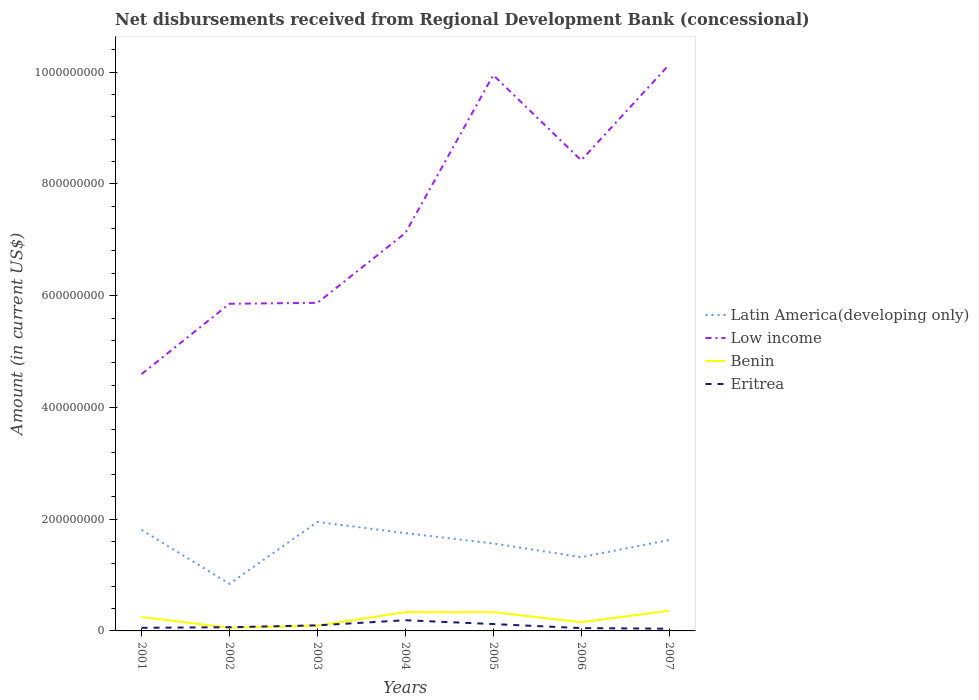How many different coloured lines are there?
Provide a succinct answer. 4. Does the line corresponding to Low income intersect with the line corresponding to Benin?
Your answer should be very brief. No. Is the number of lines equal to the number of legend labels?
Provide a succinct answer. Yes. Across all years, what is the maximum amount of disbursements received from Regional Development Bank in Benin?
Provide a short and direct response. 5.64e+06. In which year was the amount of disbursements received from Regional Development Bank in Eritrea maximum?
Offer a very short reply. 2007. What is the total amount of disbursements received from Regional Development Bank in Latin America(developing only) in the graph?
Offer a terse response. -9.08e+07. What is the difference between the highest and the second highest amount of disbursements received from Regional Development Bank in Eritrea?
Keep it short and to the point. 1.51e+07. What is the difference between the highest and the lowest amount of disbursements received from Regional Development Bank in Benin?
Provide a short and direct response. 4. Is the amount of disbursements received from Regional Development Bank in Low income strictly greater than the amount of disbursements received from Regional Development Bank in Benin over the years?
Your response must be concise. No. How many years are there in the graph?
Your answer should be very brief. 7. Where does the legend appear in the graph?
Ensure brevity in your answer.  Center right. How many legend labels are there?
Make the answer very short. 4. How are the legend labels stacked?
Your answer should be compact. Vertical. What is the title of the graph?
Your response must be concise. Net disbursements received from Regional Development Bank (concessional). Does "Spain" appear as one of the legend labels in the graph?
Keep it short and to the point. No. What is the label or title of the X-axis?
Offer a very short reply. Years. What is the Amount (in current US$) in Latin America(developing only) in 2001?
Give a very brief answer. 1.81e+08. What is the Amount (in current US$) of Low income in 2001?
Provide a succinct answer. 4.60e+08. What is the Amount (in current US$) in Benin in 2001?
Your answer should be very brief. 2.50e+07. What is the Amount (in current US$) in Eritrea in 2001?
Keep it short and to the point. 5.58e+06. What is the Amount (in current US$) in Latin America(developing only) in 2002?
Keep it short and to the point. 8.43e+07. What is the Amount (in current US$) of Low income in 2002?
Make the answer very short. 5.86e+08. What is the Amount (in current US$) in Benin in 2002?
Your answer should be very brief. 5.64e+06. What is the Amount (in current US$) of Eritrea in 2002?
Your answer should be compact. 6.65e+06. What is the Amount (in current US$) in Latin America(developing only) in 2003?
Keep it short and to the point. 1.95e+08. What is the Amount (in current US$) of Low income in 2003?
Your answer should be very brief. 5.87e+08. What is the Amount (in current US$) in Benin in 2003?
Offer a terse response. 9.45e+06. What is the Amount (in current US$) in Eritrea in 2003?
Keep it short and to the point. 9.97e+06. What is the Amount (in current US$) of Latin America(developing only) in 2004?
Your response must be concise. 1.75e+08. What is the Amount (in current US$) of Low income in 2004?
Keep it short and to the point. 7.12e+08. What is the Amount (in current US$) of Benin in 2004?
Your answer should be compact. 3.37e+07. What is the Amount (in current US$) in Eritrea in 2004?
Give a very brief answer. 1.91e+07. What is the Amount (in current US$) in Latin America(developing only) in 2005?
Offer a terse response. 1.57e+08. What is the Amount (in current US$) of Low income in 2005?
Keep it short and to the point. 9.95e+08. What is the Amount (in current US$) in Benin in 2005?
Offer a terse response. 3.36e+07. What is the Amount (in current US$) in Eritrea in 2005?
Give a very brief answer. 1.23e+07. What is the Amount (in current US$) of Latin America(developing only) in 2006?
Your answer should be very brief. 1.32e+08. What is the Amount (in current US$) of Low income in 2006?
Provide a short and direct response. 8.42e+08. What is the Amount (in current US$) in Benin in 2006?
Give a very brief answer. 1.55e+07. What is the Amount (in current US$) in Eritrea in 2006?
Your response must be concise. 5.05e+06. What is the Amount (in current US$) in Latin America(developing only) in 2007?
Give a very brief answer. 1.63e+08. What is the Amount (in current US$) of Low income in 2007?
Your answer should be compact. 1.01e+09. What is the Amount (in current US$) in Benin in 2007?
Offer a terse response. 3.63e+07. What is the Amount (in current US$) of Eritrea in 2007?
Your answer should be compact. 3.99e+06. Across all years, what is the maximum Amount (in current US$) of Latin America(developing only)?
Your answer should be compact. 1.95e+08. Across all years, what is the maximum Amount (in current US$) in Low income?
Offer a terse response. 1.01e+09. Across all years, what is the maximum Amount (in current US$) in Benin?
Give a very brief answer. 3.63e+07. Across all years, what is the maximum Amount (in current US$) of Eritrea?
Your response must be concise. 1.91e+07. Across all years, what is the minimum Amount (in current US$) of Latin America(developing only)?
Your response must be concise. 8.43e+07. Across all years, what is the minimum Amount (in current US$) of Low income?
Make the answer very short. 4.60e+08. Across all years, what is the minimum Amount (in current US$) of Benin?
Offer a terse response. 5.64e+06. Across all years, what is the minimum Amount (in current US$) in Eritrea?
Your answer should be very brief. 3.99e+06. What is the total Amount (in current US$) of Latin America(developing only) in the graph?
Give a very brief answer. 1.09e+09. What is the total Amount (in current US$) of Low income in the graph?
Your answer should be very brief. 5.20e+09. What is the total Amount (in current US$) of Benin in the graph?
Your answer should be very brief. 1.59e+08. What is the total Amount (in current US$) in Eritrea in the graph?
Ensure brevity in your answer.  6.27e+07. What is the difference between the Amount (in current US$) in Latin America(developing only) in 2001 and that in 2002?
Ensure brevity in your answer.  9.65e+07. What is the difference between the Amount (in current US$) in Low income in 2001 and that in 2002?
Provide a short and direct response. -1.26e+08. What is the difference between the Amount (in current US$) of Benin in 2001 and that in 2002?
Offer a terse response. 1.93e+07. What is the difference between the Amount (in current US$) in Eritrea in 2001 and that in 2002?
Ensure brevity in your answer.  -1.07e+06. What is the difference between the Amount (in current US$) in Latin America(developing only) in 2001 and that in 2003?
Your answer should be very brief. -1.43e+07. What is the difference between the Amount (in current US$) in Low income in 2001 and that in 2003?
Provide a succinct answer. -1.28e+08. What is the difference between the Amount (in current US$) of Benin in 2001 and that in 2003?
Ensure brevity in your answer.  1.55e+07. What is the difference between the Amount (in current US$) of Eritrea in 2001 and that in 2003?
Your answer should be very brief. -4.39e+06. What is the difference between the Amount (in current US$) in Latin America(developing only) in 2001 and that in 2004?
Make the answer very short. 5.72e+06. What is the difference between the Amount (in current US$) of Low income in 2001 and that in 2004?
Offer a very short reply. -2.53e+08. What is the difference between the Amount (in current US$) of Benin in 2001 and that in 2004?
Offer a very short reply. -8.68e+06. What is the difference between the Amount (in current US$) in Eritrea in 2001 and that in 2004?
Provide a short and direct response. -1.36e+07. What is the difference between the Amount (in current US$) in Latin America(developing only) in 2001 and that in 2005?
Your response must be concise. 2.43e+07. What is the difference between the Amount (in current US$) in Low income in 2001 and that in 2005?
Provide a short and direct response. -5.35e+08. What is the difference between the Amount (in current US$) of Benin in 2001 and that in 2005?
Keep it short and to the point. -8.61e+06. What is the difference between the Amount (in current US$) of Eritrea in 2001 and that in 2005?
Offer a very short reply. -6.71e+06. What is the difference between the Amount (in current US$) in Latin America(developing only) in 2001 and that in 2006?
Provide a succinct answer. 4.88e+07. What is the difference between the Amount (in current US$) in Low income in 2001 and that in 2006?
Your answer should be compact. -3.83e+08. What is the difference between the Amount (in current US$) in Benin in 2001 and that in 2006?
Your answer should be compact. 9.44e+06. What is the difference between the Amount (in current US$) in Eritrea in 2001 and that in 2006?
Provide a succinct answer. 5.27e+05. What is the difference between the Amount (in current US$) of Latin America(developing only) in 2001 and that in 2007?
Ensure brevity in your answer.  1.81e+07. What is the difference between the Amount (in current US$) of Low income in 2001 and that in 2007?
Your answer should be very brief. -5.54e+08. What is the difference between the Amount (in current US$) of Benin in 2001 and that in 2007?
Offer a very short reply. -1.13e+07. What is the difference between the Amount (in current US$) of Eritrea in 2001 and that in 2007?
Offer a terse response. 1.59e+06. What is the difference between the Amount (in current US$) of Latin America(developing only) in 2002 and that in 2003?
Your response must be concise. -1.11e+08. What is the difference between the Amount (in current US$) in Low income in 2002 and that in 2003?
Provide a succinct answer. -1.66e+06. What is the difference between the Amount (in current US$) of Benin in 2002 and that in 2003?
Keep it short and to the point. -3.81e+06. What is the difference between the Amount (in current US$) of Eritrea in 2002 and that in 2003?
Make the answer very short. -3.32e+06. What is the difference between the Amount (in current US$) in Latin America(developing only) in 2002 and that in 2004?
Offer a terse response. -9.08e+07. What is the difference between the Amount (in current US$) in Low income in 2002 and that in 2004?
Your answer should be very brief. -1.27e+08. What is the difference between the Amount (in current US$) of Benin in 2002 and that in 2004?
Your answer should be very brief. -2.80e+07. What is the difference between the Amount (in current US$) in Eritrea in 2002 and that in 2004?
Keep it short and to the point. -1.25e+07. What is the difference between the Amount (in current US$) in Latin America(developing only) in 2002 and that in 2005?
Your answer should be compact. -7.22e+07. What is the difference between the Amount (in current US$) in Low income in 2002 and that in 2005?
Provide a short and direct response. -4.09e+08. What is the difference between the Amount (in current US$) in Benin in 2002 and that in 2005?
Ensure brevity in your answer.  -2.80e+07. What is the difference between the Amount (in current US$) in Eritrea in 2002 and that in 2005?
Provide a short and direct response. -5.64e+06. What is the difference between the Amount (in current US$) of Latin America(developing only) in 2002 and that in 2006?
Ensure brevity in your answer.  -4.77e+07. What is the difference between the Amount (in current US$) in Low income in 2002 and that in 2006?
Your response must be concise. -2.57e+08. What is the difference between the Amount (in current US$) of Benin in 2002 and that in 2006?
Your answer should be compact. -9.90e+06. What is the difference between the Amount (in current US$) in Eritrea in 2002 and that in 2006?
Your answer should be compact. 1.60e+06. What is the difference between the Amount (in current US$) of Latin America(developing only) in 2002 and that in 2007?
Offer a very short reply. -7.84e+07. What is the difference between the Amount (in current US$) of Low income in 2002 and that in 2007?
Your answer should be very brief. -4.28e+08. What is the difference between the Amount (in current US$) of Benin in 2002 and that in 2007?
Make the answer very short. -3.06e+07. What is the difference between the Amount (in current US$) in Eritrea in 2002 and that in 2007?
Offer a very short reply. 2.66e+06. What is the difference between the Amount (in current US$) in Latin America(developing only) in 2003 and that in 2004?
Ensure brevity in your answer.  2.00e+07. What is the difference between the Amount (in current US$) in Low income in 2003 and that in 2004?
Give a very brief answer. -1.25e+08. What is the difference between the Amount (in current US$) in Benin in 2003 and that in 2004?
Give a very brief answer. -2.42e+07. What is the difference between the Amount (in current US$) of Eritrea in 2003 and that in 2004?
Make the answer very short. -9.17e+06. What is the difference between the Amount (in current US$) in Latin America(developing only) in 2003 and that in 2005?
Make the answer very short. 3.85e+07. What is the difference between the Amount (in current US$) of Low income in 2003 and that in 2005?
Your answer should be compact. -4.08e+08. What is the difference between the Amount (in current US$) of Benin in 2003 and that in 2005?
Your answer should be very brief. -2.41e+07. What is the difference between the Amount (in current US$) of Eritrea in 2003 and that in 2005?
Offer a terse response. -2.32e+06. What is the difference between the Amount (in current US$) of Latin America(developing only) in 2003 and that in 2006?
Provide a succinct answer. 6.31e+07. What is the difference between the Amount (in current US$) of Low income in 2003 and that in 2006?
Your answer should be compact. -2.55e+08. What is the difference between the Amount (in current US$) of Benin in 2003 and that in 2006?
Make the answer very short. -6.09e+06. What is the difference between the Amount (in current US$) in Eritrea in 2003 and that in 2006?
Provide a succinct answer. 4.91e+06. What is the difference between the Amount (in current US$) of Latin America(developing only) in 2003 and that in 2007?
Your response must be concise. 3.23e+07. What is the difference between the Amount (in current US$) in Low income in 2003 and that in 2007?
Your answer should be compact. -4.26e+08. What is the difference between the Amount (in current US$) of Benin in 2003 and that in 2007?
Give a very brief answer. -2.68e+07. What is the difference between the Amount (in current US$) in Eritrea in 2003 and that in 2007?
Provide a succinct answer. 5.98e+06. What is the difference between the Amount (in current US$) of Latin America(developing only) in 2004 and that in 2005?
Make the answer very short. 1.86e+07. What is the difference between the Amount (in current US$) of Low income in 2004 and that in 2005?
Your response must be concise. -2.83e+08. What is the difference between the Amount (in current US$) of Benin in 2004 and that in 2005?
Offer a very short reply. 6.90e+04. What is the difference between the Amount (in current US$) in Eritrea in 2004 and that in 2005?
Provide a succinct answer. 6.85e+06. What is the difference between the Amount (in current US$) in Latin America(developing only) in 2004 and that in 2006?
Ensure brevity in your answer.  4.31e+07. What is the difference between the Amount (in current US$) in Low income in 2004 and that in 2006?
Your response must be concise. -1.30e+08. What is the difference between the Amount (in current US$) in Benin in 2004 and that in 2006?
Your response must be concise. 1.81e+07. What is the difference between the Amount (in current US$) of Eritrea in 2004 and that in 2006?
Your response must be concise. 1.41e+07. What is the difference between the Amount (in current US$) of Latin America(developing only) in 2004 and that in 2007?
Your answer should be very brief. 1.23e+07. What is the difference between the Amount (in current US$) in Low income in 2004 and that in 2007?
Your response must be concise. -3.01e+08. What is the difference between the Amount (in current US$) of Benin in 2004 and that in 2007?
Provide a succinct answer. -2.60e+06. What is the difference between the Amount (in current US$) of Eritrea in 2004 and that in 2007?
Provide a succinct answer. 1.51e+07. What is the difference between the Amount (in current US$) in Latin America(developing only) in 2005 and that in 2006?
Your answer should be compact. 2.45e+07. What is the difference between the Amount (in current US$) in Low income in 2005 and that in 2006?
Give a very brief answer. 1.52e+08. What is the difference between the Amount (in current US$) of Benin in 2005 and that in 2006?
Make the answer very short. 1.80e+07. What is the difference between the Amount (in current US$) of Eritrea in 2005 and that in 2006?
Your answer should be very brief. 7.23e+06. What is the difference between the Amount (in current US$) of Latin America(developing only) in 2005 and that in 2007?
Offer a terse response. -6.22e+06. What is the difference between the Amount (in current US$) in Low income in 2005 and that in 2007?
Your response must be concise. -1.85e+07. What is the difference between the Amount (in current US$) in Benin in 2005 and that in 2007?
Your response must be concise. -2.66e+06. What is the difference between the Amount (in current US$) in Eritrea in 2005 and that in 2007?
Keep it short and to the point. 8.30e+06. What is the difference between the Amount (in current US$) of Latin America(developing only) in 2006 and that in 2007?
Your answer should be compact. -3.08e+07. What is the difference between the Amount (in current US$) of Low income in 2006 and that in 2007?
Your answer should be compact. -1.71e+08. What is the difference between the Amount (in current US$) of Benin in 2006 and that in 2007?
Provide a succinct answer. -2.07e+07. What is the difference between the Amount (in current US$) in Eritrea in 2006 and that in 2007?
Keep it short and to the point. 1.06e+06. What is the difference between the Amount (in current US$) in Latin America(developing only) in 2001 and the Amount (in current US$) in Low income in 2002?
Provide a succinct answer. -4.05e+08. What is the difference between the Amount (in current US$) of Latin America(developing only) in 2001 and the Amount (in current US$) of Benin in 2002?
Give a very brief answer. 1.75e+08. What is the difference between the Amount (in current US$) of Latin America(developing only) in 2001 and the Amount (in current US$) of Eritrea in 2002?
Give a very brief answer. 1.74e+08. What is the difference between the Amount (in current US$) of Low income in 2001 and the Amount (in current US$) of Benin in 2002?
Your response must be concise. 4.54e+08. What is the difference between the Amount (in current US$) in Low income in 2001 and the Amount (in current US$) in Eritrea in 2002?
Keep it short and to the point. 4.53e+08. What is the difference between the Amount (in current US$) in Benin in 2001 and the Amount (in current US$) in Eritrea in 2002?
Your response must be concise. 1.83e+07. What is the difference between the Amount (in current US$) in Latin America(developing only) in 2001 and the Amount (in current US$) in Low income in 2003?
Ensure brevity in your answer.  -4.06e+08. What is the difference between the Amount (in current US$) in Latin America(developing only) in 2001 and the Amount (in current US$) in Benin in 2003?
Keep it short and to the point. 1.71e+08. What is the difference between the Amount (in current US$) of Latin America(developing only) in 2001 and the Amount (in current US$) of Eritrea in 2003?
Make the answer very short. 1.71e+08. What is the difference between the Amount (in current US$) of Low income in 2001 and the Amount (in current US$) of Benin in 2003?
Make the answer very short. 4.50e+08. What is the difference between the Amount (in current US$) of Low income in 2001 and the Amount (in current US$) of Eritrea in 2003?
Ensure brevity in your answer.  4.50e+08. What is the difference between the Amount (in current US$) in Benin in 2001 and the Amount (in current US$) in Eritrea in 2003?
Provide a short and direct response. 1.50e+07. What is the difference between the Amount (in current US$) in Latin America(developing only) in 2001 and the Amount (in current US$) in Low income in 2004?
Your response must be concise. -5.31e+08. What is the difference between the Amount (in current US$) in Latin America(developing only) in 2001 and the Amount (in current US$) in Benin in 2004?
Make the answer very short. 1.47e+08. What is the difference between the Amount (in current US$) in Latin America(developing only) in 2001 and the Amount (in current US$) in Eritrea in 2004?
Keep it short and to the point. 1.62e+08. What is the difference between the Amount (in current US$) of Low income in 2001 and the Amount (in current US$) of Benin in 2004?
Provide a short and direct response. 4.26e+08. What is the difference between the Amount (in current US$) in Low income in 2001 and the Amount (in current US$) in Eritrea in 2004?
Keep it short and to the point. 4.41e+08. What is the difference between the Amount (in current US$) in Benin in 2001 and the Amount (in current US$) in Eritrea in 2004?
Ensure brevity in your answer.  5.85e+06. What is the difference between the Amount (in current US$) in Latin America(developing only) in 2001 and the Amount (in current US$) in Low income in 2005?
Make the answer very short. -8.14e+08. What is the difference between the Amount (in current US$) of Latin America(developing only) in 2001 and the Amount (in current US$) of Benin in 2005?
Your answer should be compact. 1.47e+08. What is the difference between the Amount (in current US$) in Latin America(developing only) in 2001 and the Amount (in current US$) in Eritrea in 2005?
Keep it short and to the point. 1.69e+08. What is the difference between the Amount (in current US$) in Low income in 2001 and the Amount (in current US$) in Benin in 2005?
Your answer should be compact. 4.26e+08. What is the difference between the Amount (in current US$) in Low income in 2001 and the Amount (in current US$) in Eritrea in 2005?
Offer a terse response. 4.47e+08. What is the difference between the Amount (in current US$) of Benin in 2001 and the Amount (in current US$) of Eritrea in 2005?
Make the answer very short. 1.27e+07. What is the difference between the Amount (in current US$) in Latin America(developing only) in 2001 and the Amount (in current US$) in Low income in 2006?
Offer a very short reply. -6.62e+08. What is the difference between the Amount (in current US$) of Latin America(developing only) in 2001 and the Amount (in current US$) of Benin in 2006?
Your answer should be compact. 1.65e+08. What is the difference between the Amount (in current US$) in Latin America(developing only) in 2001 and the Amount (in current US$) in Eritrea in 2006?
Provide a short and direct response. 1.76e+08. What is the difference between the Amount (in current US$) in Low income in 2001 and the Amount (in current US$) in Benin in 2006?
Ensure brevity in your answer.  4.44e+08. What is the difference between the Amount (in current US$) of Low income in 2001 and the Amount (in current US$) of Eritrea in 2006?
Ensure brevity in your answer.  4.55e+08. What is the difference between the Amount (in current US$) in Benin in 2001 and the Amount (in current US$) in Eritrea in 2006?
Provide a succinct answer. 1.99e+07. What is the difference between the Amount (in current US$) of Latin America(developing only) in 2001 and the Amount (in current US$) of Low income in 2007?
Offer a terse response. -8.33e+08. What is the difference between the Amount (in current US$) in Latin America(developing only) in 2001 and the Amount (in current US$) in Benin in 2007?
Your answer should be very brief. 1.45e+08. What is the difference between the Amount (in current US$) of Latin America(developing only) in 2001 and the Amount (in current US$) of Eritrea in 2007?
Offer a terse response. 1.77e+08. What is the difference between the Amount (in current US$) in Low income in 2001 and the Amount (in current US$) in Benin in 2007?
Your response must be concise. 4.23e+08. What is the difference between the Amount (in current US$) in Low income in 2001 and the Amount (in current US$) in Eritrea in 2007?
Ensure brevity in your answer.  4.56e+08. What is the difference between the Amount (in current US$) in Benin in 2001 and the Amount (in current US$) in Eritrea in 2007?
Give a very brief answer. 2.10e+07. What is the difference between the Amount (in current US$) in Latin America(developing only) in 2002 and the Amount (in current US$) in Low income in 2003?
Your response must be concise. -5.03e+08. What is the difference between the Amount (in current US$) of Latin America(developing only) in 2002 and the Amount (in current US$) of Benin in 2003?
Provide a succinct answer. 7.49e+07. What is the difference between the Amount (in current US$) of Latin America(developing only) in 2002 and the Amount (in current US$) of Eritrea in 2003?
Your response must be concise. 7.43e+07. What is the difference between the Amount (in current US$) of Low income in 2002 and the Amount (in current US$) of Benin in 2003?
Provide a succinct answer. 5.76e+08. What is the difference between the Amount (in current US$) of Low income in 2002 and the Amount (in current US$) of Eritrea in 2003?
Your answer should be very brief. 5.76e+08. What is the difference between the Amount (in current US$) of Benin in 2002 and the Amount (in current US$) of Eritrea in 2003?
Give a very brief answer. -4.33e+06. What is the difference between the Amount (in current US$) of Latin America(developing only) in 2002 and the Amount (in current US$) of Low income in 2004?
Your answer should be very brief. -6.28e+08. What is the difference between the Amount (in current US$) of Latin America(developing only) in 2002 and the Amount (in current US$) of Benin in 2004?
Provide a short and direct response. 5.06e+07. What is the difference between the Amount (in current US$) of Latin America(developing only) in 2002 and the Amount (in current US$) of Eritrea in 2004?
Ensure brevity in your answer.  6.52e+07. What is the difference between the Amount (in current US$) of Low income in 2002 and the Amount (in current US$) of Benin in 2004?
Provide a short and direct response. 5.52e+08. What is the difference between the Amount (in current US$) in Low income in 2002 and the Amount (in current US$) in Eritrea in 2004?
Your answer should be compact. 5.66e+08. What is the difference between the Amount (in current US$) in Benin in 2002 and the Amount (in current US$) in Eritrea in 2004?
Offer a very short reply. -1.35e+07. What is the difference between the Amount (in current US$) in Latin America(developing only) in 2002 and the Amount (in current US$) in Low income in 2005?
Your answer should be compact. -9.11e+08. What is the difference between the Amount (in current US$) in Latin America(developing only) in 2002 and the Amount (in current US$) in Benin in 2005?
Provide a short and direct response. 5.07e+07. What is the difference between the Amount (in current US$) in Latin America(developing only) in 2002 and the Amount (in current US$) in Eritrea in 2005?
Make the answer very short. 7.20e+07. What is the difference between the Amount (in current US$) of Low income in 2002 and the Amount (in current US$) of Benin in 2005?
Make the answer very short. 5.52e+08. What is the difference between the Amount (in current US$) in Low income in 2002 and the Amount (in current US$) in Eritrea in 2005?
Ensure brevity in your answer.  5.73e+08. What is the difference between the Amount (in current US$) in Benin in 2002 and the Amount (in current US$) in Eritrea in 2005?
Ensure brevity in your answer.  -6.65e+06. What is the difference between the Amount (in current US$) in Latin America(developing only) in 2002 and the Amount (in current US$) in Low income in 2006?
Your response must be concise. -7.58e+08. What is the difference between the Amount (in current US$) in Latin America(developing only) in 2002 and the Amount (in current US$) in Benin in 2006?
Keep it short and to the point. 6.88e+07. What is the difference between the Amount (in current US$) in Latin America(developing only) in 2002 and the Amount (in current US$) in Eritrea in 2006?
Offer a terse response. 7.93e+07. What is the difference between the Amount (in current US$) in Low income in 2002 and the Amount (in current US$) in Benin in 2006?
Keep it short and to the point. 5.70e+08. What is the difference between the Amount (in current US$) of Low income in 2002 and the Amount (in current US$) of Eritrea in 2006?
Keep it short and to the point. 5.81e+08. What is the difference between the Amount (in current US$) in Benin in 2002 and the Amount (in current US$) in Eritrea in 2006?
Ensure brevity in your answer.  5.87e+05. What is the difference between the Amount (in current US$) in Latin America(developing only) in 2002 and the Amount (in current US$) in Low income in 2007?
Offer a very short reply. -9.29e+08. What is the difference between the Amount (in current US$) of Latin America(developing only) in 2002 and the Amount (in current US$) of Benin in 2007?
Keep it short and to the point. 4.81e+07. What is the difference between the Amount (in current US$) in Latin America(developing only) in 2002 and the Amount (in current US$) in Eritrea in 2007?
Give a very brief answer. 8.03e+07. What is the difference between the Amount (in current US$) of Low income in 2002 and the Amount (in current US$) of Benin in 2007?
Offer a very short reply. 5.49e+08. What is the difference between the Amount (in current US$) of Low income in 2002 and the Amount (in current US$) of Eritrea in 2007?
Your response must be concise. 5.82e+08. What is the difference between the Amount (in current US$) in Benin in 2002 and the Amount (in current US$) in Eritrea in 2007?
Make the answer very short. 1.65e+06. What is the difference between the Amount (in current US$) in Latin America(developing only) in 2003 and the Amount (in current US$) in Low income in 2004?
Offer a very short reply. -5.17e+08. What is the difference between the Amount (in current US$) of Latin America(developing only) in 2003 and the Amount (in current US$) of Benin in 2004?
Ensure brevity in your answer.  1.61e+08. What is the difference between the Amount (in current US$) in Latin America(developing only) in 2003 and the Amount (in current US$) in Eritrea in 2004?
Provide a short and direct response. 1.76e+08. What is the difference between the Amount (in current US$) in Low income in 2003 and the Amount (in current US$) in Benin in 2004?
Provide a short and direct response. 5.54e+08. What is the difference between the Amount (in current US$) in Low income in 2003 and the Amount (in current US$) in Eritrea in 2004?
Offer a very short reply. 5.68e+08. What is the difference between the Amount (in current US$) in Benin in 2003 and the Amount (in current US$) in Eritrea in 2004?
Your answer should be compact. -9.68e+06. What is the difference between the Amount (in current US$) in Latin America(developing only) in 2003 and the Amount (in current US$) in Low income in 2005?
Your response must be concise. -8.00e+08. What is the difference between the Amount (in current US$) of Latin America(developing only) in 2003 and the Amount (in current US$) of Benin in 2005?
Keep it short and to the point. 1.61e+08. What is the difference between the Amount (in current US$) in Latin America(developing only) in 2003 and the Amount (in current US$) in Eritrea in 2005?
Your answer should be compact. 1.83e+08. What is the difference between the Amount (in current US$) of Low income in 2003 and the Amount (in current US$) of Benin in 2005?
Make the answer very short. 5.54e+08. What is the difference between the Amount (in current US$) in Low income in 2003 and the Amount (in current US$) in Eritrea in 2005?
Offer a terse response. 5.75e+08. What is the difference between the Amount (in current US$) of Benin in 2003 and the Amount (in current US$) of Eritrea in 2005?
Ensure brevity in your answer.  -2.84e+06. What is the difference between the Amount (in current US$) of Latin America(developing only) in 2003 and the Amount (in current US$) of Low income in 2006?
Keep it short and to the point. -6.47e+08. What is the difference between the Amount (in current US$) in Latin America(developing only) in 2003 and the Amount (in current US$) in Benin in 2006?
Keep it short and to the point. 1.80e+08. What is the difference between the Amount (in current US$) of Latin America(developing only) in 2003 and the Amount (in current US$) of Eritrea in 2006?
Provide a succinct answer. 1.90e+08. What is the difference between the Amount (in current US$) of Low income in 2003 and the Amount (in current US$) of Benin in 2006?
Your answer should be very brief. 5.72e+08. What is the difference between the Amount (in current US$) in Low income in 2003 and the Amount (in current US$) in Eritrea in 2006?
Offer a terse response. 5.82e+08. What is the difference between the Amount (in current US$) in Benin in 2003 and the Amount (in current US$) in Eritrea in 2006?
Give a very brief answer. 4.40e+06. What is the difference between the Amount (in current US$) of Latin America(developing only) in 2003 and the Amount (in current US$) of Low income in 2007?
Make the answer very short. -8.18e+08. What is the difference between the Amount (in current US$) of Latin America(developing only) in 2003 and the Amount (in current US$) of Benin in 2007?
Offer a terse response. 1.59e+08. What is the difference between the Amount (in current US$) of Latin America(developing only) in 2003 and the Amount (in current US$) of Eritrea in 2007?
Your response must be concise. 1.91e+08. What is the difference between the Amount (in current US$) of Low income in 2003 and the Amount (in current US$) of Benin in 2007?
Provide a succinct answer. 5.51e+08. What is the difference between the Amount (in current US$) of Low income in 2003 and the Amount (in current US$) of Eritrea in 2007?
Make the answer very short. 5.83e+08. What is the difference between the Amount (in current US$) of Benin in 2003 and the Amount (in current US$) of Eritrea in 2007?
Offer a very short reply. 5.46e+06. What is the difference between the Amount (in current US$) of Latin America(developing only) in 2004 and the Amount (in current US$) of Low income in 2005?
Your answer should be very brief. -8.20e+08. What is the difference between the Amount (in current US$) of Latin America(developing only) in 2004 and the Amount (in current US$) of Benin in 2005?
Offer a terse response. 1.41e+08. What is the difference between the Amount (in current US$) in Latin America(developing only) in 2004 and the Amount (in current US$) in Eritrea in 2005?
Your response must be concise. 1.63e+08. What is the difference between the Amount (in current US$) of Low income in 2004 and the Amount (in current US$) of Benin in 2005?
Your answer should be very brief. 6.79e+08. What is the difference between the Amount (in current US$) of Low income in 2004 and the Amount (in current US$) of Eritrea in 2005?
Offer a terse response. 7.00e+08. What is the difference between the Amount (in current US$) in Benin in 2004 and the Amount (in current US$) in Eritrea in 2005?
Offer a terse response. 2.14e+07. What is the difference between the Amount (in current US$) of Latin America(developing only) in 2004 and the Amount (in current US$) of Low income in 2006?
Provide a succinct answer. -6.67e+08. What is the difference between the Amount (in current US$) in Latin America(developing only) in 2004 and the Amount (in current US$) in Benin in 2006?
Your answer should be very brief. 1.60e+08. What is the difference between the Amount (in current US$) in Latin America(developing only) in 2004 and the Amount (in current US$) in Eritrea in 2006?
Provide a short and direct response. 1.70e+08. What is the difference between the Amount (in current US$) in Low income in 2004 and the Amount (in current US$) in Benin in 2006?
Make the answer very short. 6.97e+08. What is the difference between the Amount (in current US$) of Low income in 2004 and the Amount (in current US$) of Eritrea in 2006?
Your answer should be very brief. 7.07e+08. What is the difference between the Amount (in current US$) of Benin in 2004 and the Amount (in current US$) of Eritrea in 2006?
Provide a short and direct response. 2.86e+07. What is the difference between the Amount (in current US$) of Latin America(developing only) in 2004 and the Amount (in current US$) of Low income in 2007?
Ensure brevity in your answer.  -8.38e+08. What is the difference between the Amount (in current US$) in Latin America(developing only) in 2004 and the Amount (in current US$) in Benin in 2007?
Offer a very short reply. 1.39e+08. What is the difference between the Amount (in current US$) of Latin America(developing only) in 2004 and the Amount (in current US$) of Eritrea in 2007?
Your answer should be compact. 1.71e+08. What is the difference between the Amount (in current US$) of Low income in 2004 and the Amount (in current US$) of Benin in 2007?
Your answer should be very brief. 6.76e+08. What is the difference between the Amount (in current US$) of Low income in 2004 and the Amount (in current US$) of Eritrea in 2007?
Ensure brevity in your answer.  7.08e+08. What is the difference between the Amount (in current US$) in Benin in 2004 and the Amount (in current US$) in Eritrea in 2007?
Your response must be concise. 2.97e+07. What is the difference between the Amount (in current US$) of Latin America(developing only) in 2005 and the Amount (in current US$) of Low income in 2006?
Give a very brief answer. -6.86e+08. What is the difference between the Amount (in current US$) of Latin America(developing only) in 2005 and the Amount (in current US$) of Benin in 2006?
Ensure brevity in your answer.  1.41e+08. What is the difference between the Amount (in current US$) in Latin America(developing only) in 2005 and the Amount (in current US$) in Eritrea in 2006?
Provide a short and direct response. 1.51e+08. What is the difference between the Amount (in current US$) of Low income in 2005 and the Amount (in current US$) of Benin in 2006?
Your answer should be very brief. 9.79e+08. What is the difference between the Amount (in current US$) of Low income in 2005 and the Amount (in current US$) of Eritrea in 2006?
Give a very brief answer. 9.90e+08. What is the difference between the Amount (in current US$) of Benin in 2005 and the Amount (in current US$) of Eritrea in 2006?
Make the answer very short. 2.85e+07. What is the difference between the Amount (in current US$) in Latin America(developing only) in 2005 and the Amount (in current US$) in Low income in 2007?
Your answer should be compact. -8.57e+08. What is the difference between the Amount (in current US$) of Latin America(developing only) in 2005 and the Amount (in current US$) of Benin in 2007?
Give a very brief answer. 1.20e+08. What is the difference between the Amount (in current US$) in Latin America(developing only) in 2005 and the Amount (in current US$) in Eritrea in 2007?
Your answer should be compact. 1.53e+08. What is the difference between the Amount (in current US$) in Low income in 2005 and the Amount (in current US$) in Benin in 2007?
Give a very brief answer. 9.59e+08. What is the difference between the Amount (in current US$) in Low income in 2005 and the Amount (in current US$) in Eritrea in 2007?
Make the answer very short. 9.91e+08. What is the difference between the Amount (in current US$) in Benin in 2005 and the Amount (in current US$) in Eritrea in 2007?
Your response must be concise. 2.96e+07. What is the difference between the Amount (in current US$) in Latin America(developing only) in 2006 and the Amount (in current US$) in Low income in 2007?
Give a very brief answer. -8.81e+08. What is the difference between the Amount (in current US$) of Latin America(developing only) in 2006 and the Amount (in current US$) of Benin in 2007?
Offer a terse response. 9.57e+07. What is the difference between the Amount (in current US$) in Latin America(developing only) in 2006 and the Amount (in current US$) in Eritrea in 2007?
Your answer should be very brief. 1.28e+08. What is the difference between the Amount (in current US$) of Low income in 2006 and the Amount (in current US$) of Benin in 2007?
Keep it short and to the point. 8.06e+08. What is the difference between the Amount (in current US$) in Low income in 2006 and the Amount (in current US$) in Eritrea in 2007?
Your answer should be very brief. 8.38e+08. What is the difference between the Amount (in current US$) of Benin in 2006 and the Amount (in current US$) of Eritrea in 2007?
Make the answer very short. 1.16e+07. What is the average Amount (in current US$) in Latin America(developing only) per year?
Provide a succinct answer. 1.55e+08. What is the average Amount (in current US$) in Low income per year?
Your response must be concise. 7.42e+08. What is the average Amount (in current US$) in Benin per year?
Your answer should be compact. 2.27e+07. What is the average Amount (in current US$) of Eritrea per year?
Give a very brief answer. 8.95e+06. In the year 2001, what is the difference between the Amount (in current US$) of Latin America(developing only) and Amount (in current US$) of Low income?
Ensure brevity in your answer.  -2.79e+08. In the year 2001, what is the difference between the Amount (in current US$) in Latin America(developing only) and Amount (in current US$) in Benin?
Your answer should be compact. 1.56e+08. In the year 2001, what is the difference between the Amount (in current US$) in Latin America(developing only) and Amount (in current US$) in Eritrea?
Offer a terse response. 1.75e+08. In the year 2001, what is the difference between the Amount (in current US$) of Low income and Amount (in current US$) of Benin?
Keep it short and to the point. 4.35e+08. In the year 2001, what is the difference between the Amount (in current US$) in Low income and Amount (in current US$) in Eritrea?
Provide a succinct answer. 4.54e+08. In the year 2001, what is the difference between the Amount (in current US$) in Benin and Amount (in current US$) in Eritrea?
Give a very brief answer. 1.94e+07. In the year 2002, what is the difference between the Amount (in current US$) of Latin America(developing only) and Amount (in current US$) of Low income?
Your answer should be very brief. -5.01e+08. In the year 2002, what is the difference between the Amount (in current US$) of Latin America(developing only) and Amount (in current US$) of Benin?
Provide a short and direct response. 7.87e+07. In the year 2002, what is the difference between the Amount (in current US$) of Latin America(developing only) and Amount (in current US$) of Eritrea?
Your answer should be compact. 7.77e+07. In the year 2002, what is the difference between the Amount (in current US$) of Low income and Amount (in current US$) of Benin?
Provide a short and direct response. 5.80e+08. In the year 2002, what is the difference between the Amount (in current US$) in Low income and Amount (in current US$) in Eritrea?
Provide a short and direct response. 5.79e+08. In the year 2002, what is the difference between the Amount (in current US$) in Benin and Amount (in current US$) in Eritrea?
Your response must be concise. -1.01e+06. In the year 2003, what is the difference between the Amount (in current US$) in Latin America(developing only) and Amount (in current US$) in Low income?
Give a very brief answer. -3.92e+08. In the year 2003, what is the difference between the Amount (in current US$) of Latin America(developing only) and Amount (in current US$) of Benin?
Make the answer very short. 1.86e+08. In the year 2003, what is the difference between the Amount (in current US$) in Latin America(developing only) and Amount (in current US$) in Eritrea?
Provide a succinct answer. 1.85e+08. In the year 2003, what is the difference between the Amount (in current US$) of Low income and Amount (in current US$) of Benin?
Your answer should be very brief. 5.78e+08. In the year 2003, what is the difference between the Amount (in current US$) of Low income and Amount (in current US$) of Eritrea?
Offer a terse response. 5.77e+08. In the year 2003, what is the difference between the Amount (in current US$) of Benin and Amount (in current US$) of Eritrea?
Ensure brevity in your answer.  -5.15e+05. In the year 2004, what is the difference between the Amount (in current US$) in Latin America(developing only) and Amount (in current US$) in Low income?
Make the answer very short. -5.37e+08. In the year 2004, what is the difference between the Amount (in current US$) of Latin America(developing only) and Amount (in current US$) of Benin?
Ensure brevity in your answer.  1.41e+08. In the year 2004, what is the difference between the Amount (in current US$) of Latin America(developing only) and Amount (in current US$) of Eritrea?
Your answer should be compact. 1.56e+08. In the year 2004, what is the difference between the Amount (in current US$) of Low income and Amount (in current US$) of Benin?
Your answer should be compact. 6.78e+08. In the year 2004, what is the difference between the Amount (in current US$) in Low income and Amount (in current US$) in Eritrea?
Keep it short and to the point. 6.93e+08. In the year 2004, what is the difference between the Amount (in current US$) of Benin and Amount (in current US$) of Eritrea?
Provide a short and direct response. 1.45e+07. In the year 2005, what is the difference between the Amount (in current US$) in Latin America(developing only) and Amount (in current US$) in Low income?
Ensure brevity in your answer.  -8.38e+08. In the year 2005, what is the difference between the Amount (in current US$) of Latin America(developing only) and Amount (in current US$) of Benin?
Ensure brevity in your answer.  1.23e+08. In the year 2005, what is the difference between the Amount (in current US$) of Latin America(developing only) and Amount (in current US$) of Eritrea?
Ensure brevity in your answer.  1.44e+08. In the year 2005, what is the difference between the Amount (in current US$) of Low income and Amount (in current US$) of Benin?
Ensure brevity in your answer.  9.61e+08. In the year 2005, what is the difference between the Amount (in current US$) of Low income and Amount (in current US$) of Eritrea?
Provide a short and direct response. 9.83e+08. In the year 2005, what is the difference between the Amount (in current US$) in Benin and Amount (in current US$) in Eritrea?
Your answer should be very brief. 2.13e+07. In the year 2006, what is the difference between the Amount (in current US$) in Latin America(developing only) and Amount (in current US$) in Low income?
Your answer should be compact. -7.10e+08. In the year 2006, what is the difference between the Amount (in current US$) of Latin America(developing only) and Amount (in current US$) of Benin?
Ensure brevity in your answer.  1.16e+08. In the year 2006, what is the difference between the Amount (in current US$) of Latin America(developing only) and Amount (in current US$) of Eritrea?
Offer a terse response. 1.27e+08. In the year 2006, what is the difference between the Amount (in current US$) in Low income and Amount (in current US$) in Benin?
Offer a terse response. 8.27e+08. In the year 2006, what is the difference between the Amount (in current US$) in Low income and Amount (in current US$) in Eritrea?
Your answer should be very brief. 8.37e+08. In the year 2006, what is the difference between the Amount (in current US$) in Benin and Amount (in current US$) in Eritrea?
Give a very brief answer. 1.05e+07. In the year 2007, what is the difference between the Amount (in current US$) in Latin America(developing only) and Amount (in current US$) in Low income?
Offer a very short reply. -8.51e+08. In the year 2007, what is the difference between the Amount (in current US$) in Latin America(developing only) and Amount (in current US$) in Benin?
Keep it short and to the point. 1.26e+08. In the year 2007, what is the difference between the Amount (in current US$) in Latin America(developing only) and Amount (in current US$) in Eritrea?
Provide a succinct answer. 1.59e+08. In the year 2007, what is the difference between the Amount (in current US$) in Low income and Amount (in current US$) in Benin?
Your answer should be compact. 9.77e+08. In the year 2007, what is the difference between the Amount (in current US$) of Low income and Amount (in current US$) of Eritrea?
Offer a very short reply. 1.01e+09. In the year 2007, what is the difference between the Amount (in current US$) in Benin and Amount (in current US$) in Eritrea?
Your answer should be very brief. 3.23e+07. What is the ratio of the Amount (in current US$) in Latin America(developing only) in 2001 to that in 2002?
Your answer should be compact. 2.14. What is the ratio of the Amount (in current US$) in Low income in 2001 to that in 2002?
Your response must be concise. 0.78. What is the ratio of the Amount (in current US$) of Benin in 2001 to that in 2002?
Your response must be concise. 4.43. What is the ratio of the Amount (in current US$) of Eritrea in 2001 to that in 2002?
Give a very brief answer. 0.84. What is the ratio of the Amount (in current US$) in Latin America(developing only) in 2001 to that in 2003?
Your response must be concise. 0.93. What is the ratio of the Amount (in current US$) in Low income in 2001 to that in 2003?
Ensure brevity in your answer.  0.78. What is the ratio of the Amount (in current US$) of Benin in 2001 to that in 2003?
Keep it short and to the point. 2.64. What is the ratio of the Amount (in current US$) of Eritrea in 2001 to that in 2003?
Ensure brevity in your answer.  0.56. What is the ratio of the Amount (in current US$) of Latin America(developing only) in 2001 to that in 2004?
Provide a succinct answer. 1.03. What is the ratio of the Amount (in current US$) in Low income in 2001 to that in 2004?
Offer a terse response. 0.65. What is the ratio of the Amount (in current US$) in Benin in 2001 to that in 2004?
Offer a very short reply. 0.74. What is the ratio of the Amount (in current US$) of Eritrea in 2001 to that in 2004?
Provide a short and direct response. 0.29. What is the ratio of the Amount (in current US$) in Latin America(developing only) in 2001 to that in 2005?
Ensure brevity in your answer.  1.16. What is the ratio of the Amount (in current US$) of Low income in 2001 to that in 2005?
Provide a short and direct response. 0.46. What is the ratio of the Amount (in current US$) of Benin in 2001 to that in 2005?
Provide a short and direct response. 0.74. What is the ratio of the Amount (in current US$) of Eritrea in 2001 to that in 2005?
Offer a very short reply. 0.45. What is the ratio of the Amount (in current US$) in Latin America(developing only) in 2001 to that in 2006?
Ensure brevity in your answer.  1.37. What is the ratio of the Amount (in current US$) of Low income in 2001 to that in 2006?
Provide a succinct answer. 0.55. What is the ratio of the Amount (in current US$) of Benin in 2001 to that in 2006?
Provide a short and direct response. 1.61. What is the ratio of the Amount (in current US$) in Eritrea in 2001 to that in 2006?
Offer a very short reply. 1.1. What is the ratio of the Amount (in current US$) in Latin America(developing only) in 2001 to that in 2007?
Keep it short and to the point. 1.11. What is the ratio of the Amount (in current US$) in Low income in 2001 to that in 2007?
Your response must be concise. 0.45. What is the ratio of the Amount (in current US$) in Benin in 2001 to that in 2007?
Offer a terse response. 0.69. What is the ratio of the Amount (in current US$) of Eritrea in 2001 to that in 2007?
Your response must be concise. 1.4. What is the ratio of the Amount (in current US$) of Latin America(developing only) in 2002 to that in 2003?
Your answer should be very brief. 0.43. What is the ratio of the Amount (in current US$) in Benin in 2002 to that in 2003?
Ensure brevity in your answer.  0.6. What is the ratio of the Amount (in current US$) in Eritrea in 2002 to that in 2003?
Offer a very short reply. 0.67. What is the ratio of the Amount (in current US$) in Latin America(developing only) in 2002 to that in 2004?
Your answer should be compact. 0.48. What is the ratio of the Amount (in current US$) in Low income in 2002 to that in 2004?
Make the answer very short. 0.82. What is the ratio of the Amount (in current US$) of Benin in 2002 to that in 2004?
Provide a short and direct response. 0.17. What is the ratio of the Amount (in current US$) in Eritrea in 2002 to that in 2004?
Offer a terse response. 0.35. What is the ratio of the Amount (in current US$) in Latin America(developing only) in 2002 to that in 2005?
Offer a terse response. 0.54. What is the ratio of the Amount (in current US$) of Low income in 2002 to that in 2005?
Offer a very short reply. 0.59. What is the ratio of the Amount (in current US$) in Benin in 2002 to that in 2005?
Your response must be concise. 0.17. What is the ratio of the Amount (in current US$) of Eritrea in 2002 to that in 2005?
Offer a terse response. 0.54. What is the ratio of the Amount (in current US$) of Latin America(developing only) in 2002 to that in 2006?
Ensure brevity in your answer.  0.64. What is the ratio of the Amount (in current US$) in Low income in 2002 to that in 2006?
Offer a terse response. 0.7. What is the ratio of the Amount (in current US$) in Benin in 2002 to that in 2006?
Keep it short and to the point. 0.36. What is the ratio of the Amount (in current US$) of Eritrea in 2002 to that in 2006?
Offer a very short reply. 1.32. What is the ratio of the Amount (in current US$) in Latin America(developing only) in 2002 to that in 2007?
Give a very brief answer. 0.52. What is the ratio of the Amount (in current US$) in Low income in 2002 to that in 2007?
Give a very brief answer. 0.58. What is the ratio of the Amount (in current US$) in Benin in 2002 to that in 2007?
Keep it short and to the point. 0.16. What is the ratio of the Amount (in current US$) of Eritrea in 2002 to that in 2007?
Make the answer very short. 1.67. What is the ratio of the Amount (in current US$) of Latin America(developing only) in 2003 to that in 2004?
Offer a terse response. 1.11. What is the ratio of the Amount (in current US$) in Low income in 2003 to that in 2004?
Offer a terse response. 0.82. What is the ratio of the Amount (in current US$) of Benin in 2003 to that in 2004?
Your response must be concise. 0.28. What is the ratio of the Amount (in current US$) of Eritrea in 2003 to that in 2004?
Your response must be concise. 0.52. What is the ratio of the Amount (in current US$) of Latin America(developing only) in 2003 to that in 2005?
Offer a very short reply. 1.25. What is the ratio of the Amount (in current US$) in Low income in 2003 to that in 2005?
Your answer should be very brief. 0.59. What is the ratio of the Amount (in current US$) in Benin in 2003 to that in 2005?
Your answer should be compact. 0.28. What is the ratio of the Amount (in current US$) of Eritrea in 2003 to that in 2005?
Your answer should be compact. 0.81. What is the ratio of the Amount (in current US$) of Latin America(developing only) in 2003 to that in 2006?
Provide a succinct answer. 1.48. What is the ratio of the Amount (in current US$) in Low income in 2003 to that in 2006?
Give a very brief answer. 0.7. What is the ratio of the Amount (in current US$) of Benin in 2003 to that in 2006?
Your answer should be compact. 0.61. What is the ratio of the Amount (in current US$) in Eritrea in 2003 to that in 2006?
Offer a terse response. 1.97. What is the ratio of the Amount (in current US$) of Latin America(developing only) in 2003 to that in 2007?
Offer a very short reply. 1.2. What is the ratio of the Amount (in current US$) in Low income in 2003 to that in 2007?
Offer a terse response. 0.58. What is the ratio of the Amount (in current US$) in Benin in 2003 to that in 2007?
Your answer should be very brief. 0.26. What is the ratio of the Amount (in current US$) in Eritrea in 2003 to that in 2007?
Provide a short and direct response. 2.5. What is the ratio of the Amount (in current US$) in Latin America(developing only) in 2004 to that in 2005?
Make the answer very short. 1.12. What is the ratio of the Amount (in current US$) in Low income in 2004 to that in 2005?
Provide a succinct answer. 0.72. What is the ratio of the Amount (in current US$) in Eritrea in 2004 to that in 2005?
Provide a short and direct response. 1.56. What is the ratio of the Amount (in current US$) of Latin America(developing only) in 2004 to that in 2006?
Ensure brevity in your answer.  1.33. What is the ratio of the Amount (in current US$) of Low income in 2004 to that in 2006?
Provide a succinct answer. 0.85. What is the ratio of the Amount (in current US$) of Benin in 2004 to that in 2006?
Make the answer very short. 2.17. What is the ratio of the Amount (in current US$) in Eritrea in 2004 to that in 2006?
Your response must be concise. 3.79. What is the ratio of the Amount (in current US$) of Latin America(developing only) in 2004 to that in 2007?
Offer a very short reply. 1.08. What is the ratio of the Amount (in current US$) in Low income in 2004 to that in 2007?
Offer a very short reply. 0.7. What is the ratio of the Amount (in current US$) in Benin in 2004 to that in 2007?
Your answer should be very brief. 0.93. What is the ratio of the Amount (in current US$) of Eritrea in 2004 to that in 2007?
Provide a succinct answer. 4.79. What is the ratio of the Amount (in current US$) in Latin America(developing only) in 2005 to that in 2006?
Ensure brevity in your answer.  1.19. What is the ratio of the Amount (in current US$) of Low income in 2005 to that in 2006?
Keep it short and to the point. 1.18. What is the ratio of the Amount (in current US$) of Benin in 2005 to that in 2006?
Your response must be concise. 2.16. What is the ratio of the Amount (in current US$) in Eritrea in 2005 to that in 2006?
Ensure brevity in your answer.  2.43. What is the ratio of the Amount (in current US$) in Latin America(developing only) in 2005 to that in 2007?
Your response must be concise. 0.96. What is the ratio of the Amount (in current US$) in Low income in 2005 to that in 2007?
Provide a short and direct response. 0.98. What is the ratio of the Amount (in current US$) in Benin in 2005 to that in 2007?
Provide a succinct answer. 0.93. What is the ratio of the Amount (in current US$) in Eritrea in 2005 to that in 2007?
Keep it short and to the point. 3.08. What is the ratio of the Amount (in current US$) in Latin America(developing only) in 2006 to that in 2007?
Your answer should be very brief. 0.81. What is the ratio of the Amount (in current US$) in Low income in 2006 to that in 2007?
Provide a succinct answer. 0.83. What is the ratio of the Amount (in current US$) of Benin in 2006 to that in 2007?
Your answer should be very brief. 0.43. What is the ratio of the Amount (in current US$) in Eritrea in 2006 to that in 2007?
Offer a very short reply. 1.27. What is the difference between the highest and the second highest Amount (in current US$) in Latin America(developing only)?
Provide a short and direct response. 1.43e+07. What is the difference between the highest and the second highest Amount (in current US$) of Low income?
Provide a short and direct response. 1.85e+07. What is the difference between the highest and the second highest Amount (in current US$) in Benin?
Make the answer very short. 2.60e+06. What is the difference between the highest and the second highest Amount (in current US$) of Eritrea?
Provide a short and direct response. 6.85e+06. What is the difference between the highest and the lowest Amount (in current US$) in Latin America(developing only)?
Offer a very short reply. 1.11e+08. What is the difference between the highest and the lowest Amount (in current US$) in Low income?
Provide a succinct answer. 5.54e+08. What is the difference between the highest and the lowest Amount (in current US$) of Benin?
Provide a succinct answer. 3.06e+07. What is the difference between the highest and the lowest Amount (in current US$) in Eritrea?
Your answer should be very brief. 1.51e+07. 